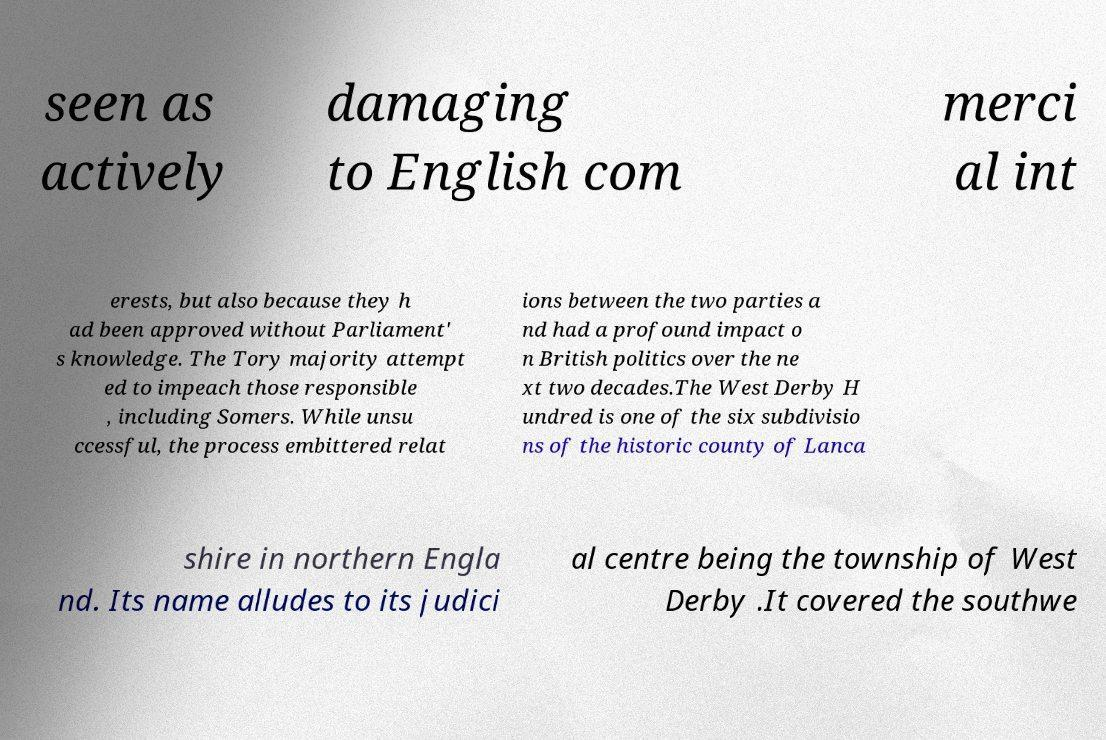What messages or text are displayed in this image? I need them in a readable, typed format. seen as actively damaging to English com merci al int erests, but also because they h ad been approved without Parliament' s knowledge. The Tory majority attempt ed to impeach those responsible , including Somers. While unsu ccessful, the process embittered relat ions between the two parties a nd had a profound impact o n British politics over the ne xt two decades.The West Derby H undred is one of the six subdivisio ns of the historic county of Lanca shire in northern Engla nd. Its name alludes to its judici al centre being the township of West Derby .It covered the southwe 